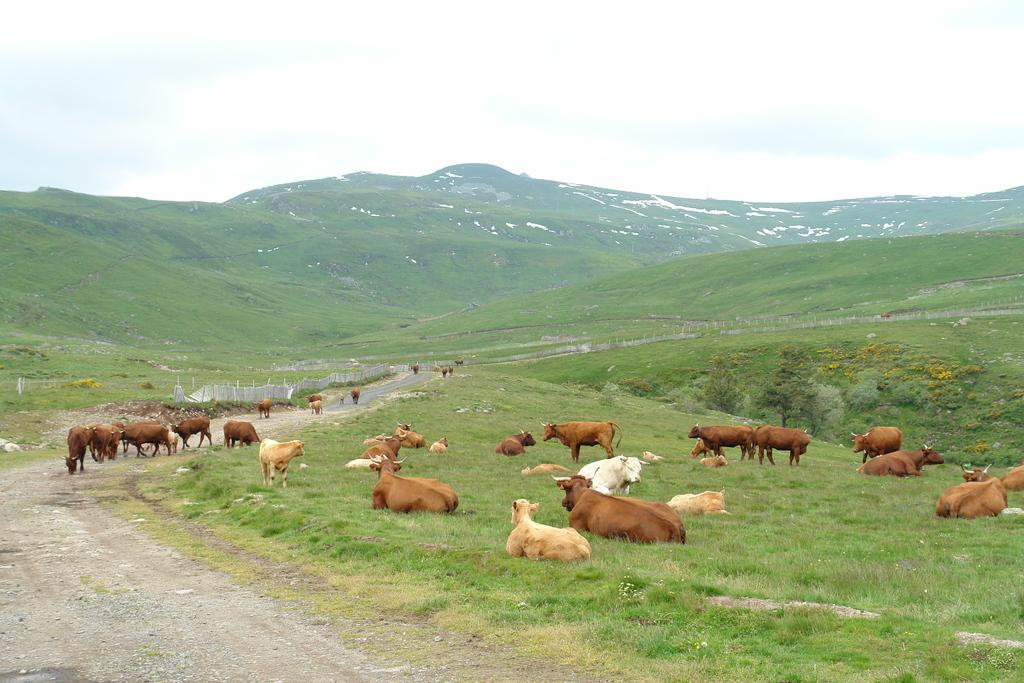What type of living organisms can be seen in the image? There are animals in the image. What type of vegetation is at the bottom of the image? There is grass at the bottom of the image. What can be seen in the background of the image? Hills and sky are visible in the background of the image. What type of barrier is present in the image? There is a fence in the image. How does the knowledge of the animals in the image help them smash through the fence? The image does not depict any knowledge or smashing through the fence; it simply shows animals, grass, hills, sky, and a fence. 